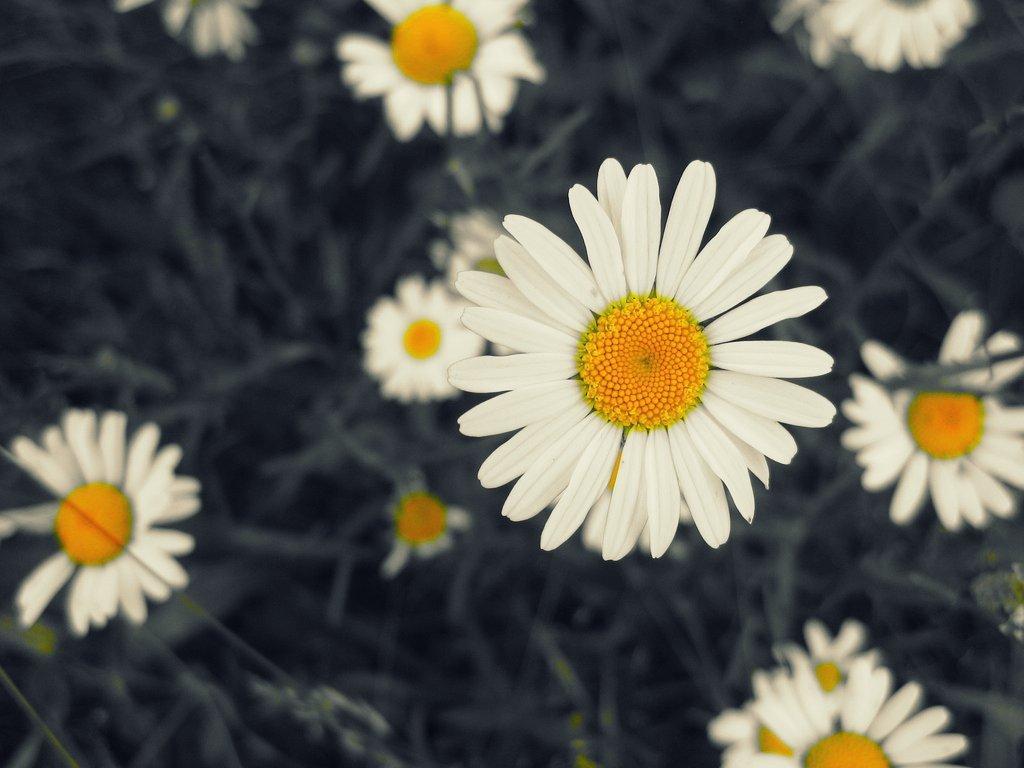Could you give a brief overview of what you see in this image? This is the picture of a few flowers which are in white and yellow. We can also see the picture is blurred in the background. 